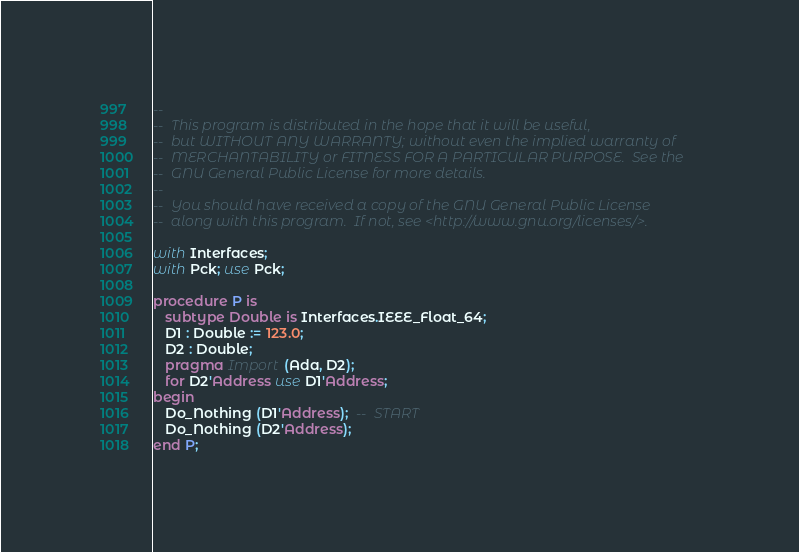Convert code to text. <code><loc_0><loc_0><loc_500><loc_500><_Ada_>--
--  This program is distributed in the hope that it will be useful,
--  but WITHOUT ANY WARRANTY; without even the implied warranty of
--  MERCHANTABILITY or FITNESS FOR A PARTICULAR PURPOSE.  See the
--  GNU General Public License for more details.
--
--  You should have received a copy of the GNU General Public License
--  along with this program.  If not, see <http://www.gnu.org/licenses/>.

with Interfaces;
with Pck; use Pck;

procedure P is
   subtype Double is Interfaces.IEEE_Float_64;
   D1 : Double := 123.0;
   D2 : Double;
   pragma Import (Ada, D2);
   for D2'Address use D1'Address;
begin
   Do_Nothing (D1'Address);  --  START
   Do_Nothing (D2'Address);
end P;

</code> 